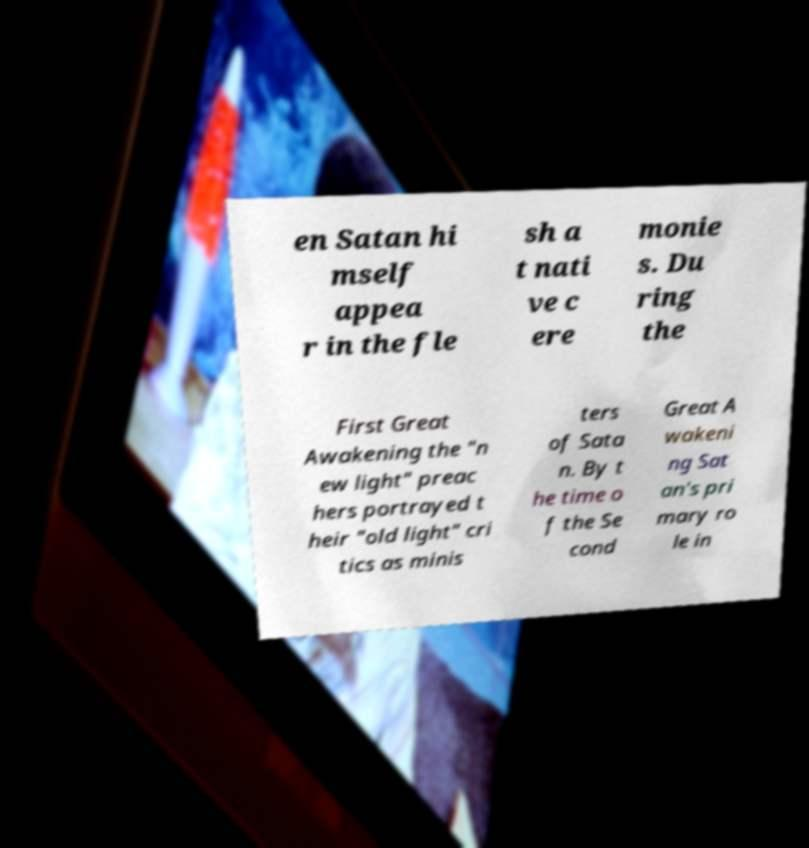Can you accurately transcribe the text from the provided image for me? en Satan hi mself appea r in the fle sh a t nati ve c ere monie s. Du ring the First Great Awakening the "n ew light" preac hers portrayed t heir "old light" cri tics as minis ters of Sata n. By t he time o f the Se cond Great A wakeni ng Sat an's pri mary ro le in 